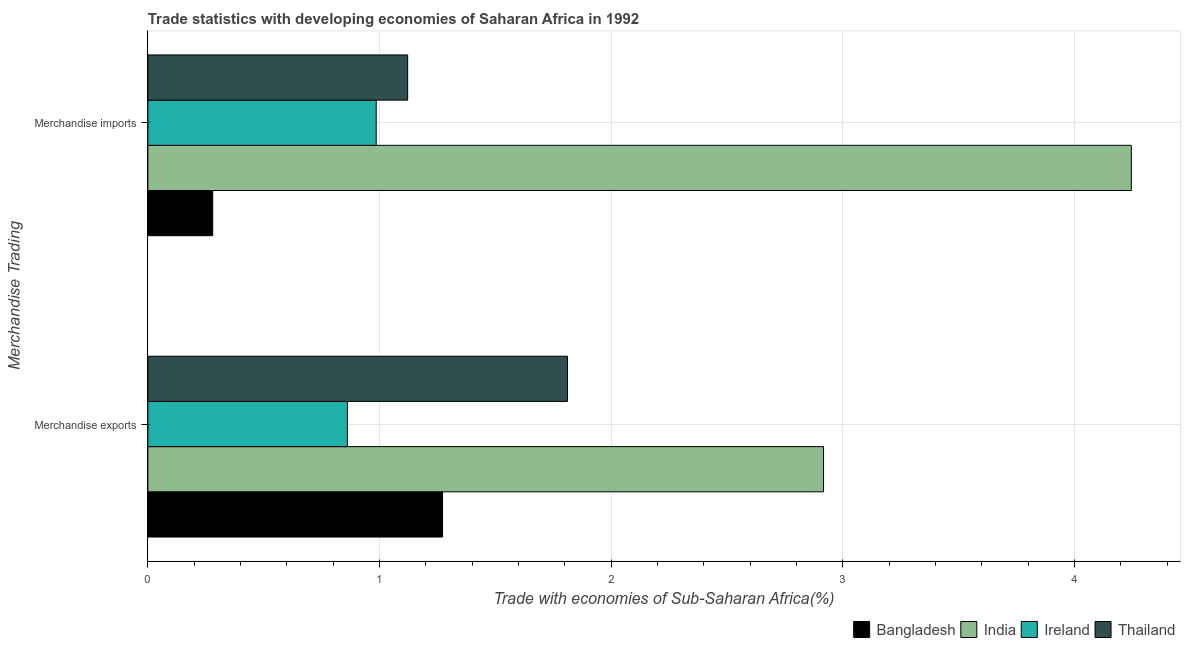How many different coloured bars are there?
Ensure brevity in your answer.  4. How many groups of bars are there?
Offer a terse response. 2. Are the number of bars per tick equal to the number of legend labels?
Offer a very short reply. Yes. What is the label of the 2nd group of bars from the top?
Your answer should be very brief. Merchandise exports. What is the merchandise exports in Bangladesh?
Provide a short and direct response. 1.27. Across all countries, what is the maximum merchandise imports?
Your answer should be very brief. 4.24. Across all countries, what is the minimum merchandise exports?
Give a very brief answer. 0.86. In which country was the merchandise imports minimum?
Your answer should be very brief. Bangladesh. What is the total merchandise imports in the graph?
Your response must be concise. 6.63. What is the difference between the merchandise exports in Bangladesh and that in India?
Keep it short and to the point. -1.64. What is the difference between the merchandise imports in India and the merchandise exports in Bangladesh?
Offer a terse response. 2.97. What is the average merchandise exports per country?
Your answer should be very brief. 1.72. What is the difference between the merchandise imports and merchandise exports in Bangladesh?
Your answer should be compact. -0.99. In how many countries, is the merchandise imports greater than 3 %?
Provide a succinct answer. 1. What is the ratio of the merchandise imports in Thailand to that in Bangladesh?
Your answer should be compact. 4.01. Is the merchandise imports in Bangladesh less than that in India?
Make the answer very short. Yes. What does the 2nd bar from the top in Merchandise imports represents?
Your answer should be very brief. Ireland. What does the 2nd bar from the bottom in Merchandise imports represents?
Give a very brief answer. India. Are the values on the major ticks of X-axis written in scientific E-notation?
Make the answer very short. No. How many legend labels are there?
Provide a short and direct response. 4. How are the legend labels stacked?
Give a very brief answer. Horizontal. What is the title of the graph?
Your answer should be compact. Trade statistics with developing economies of Saharan Africa in 1992. What is the label or title of the X-axis?
Provide a succinct answer. Trade with economies of Sub-Saharan Africa(%). What is the label or title of the Y-axis?
Provide a short and direct response. Merchandise Trading. What is the Trade with economies of Sub-Saharan Africa(%) in Bangladesh in Merchandise exports?
Keep it short and to the point. 1.27. What is the Trade with economies of Sub-Saharan Africa(%) in India in Merchandise exports?
Give a very brief answer. 2.92. What is the Trade with economies of Sub-Saharan Africa(%) of Ireland in Merchandise exports?
Your answer should be compact. 0.86. What is the Trade with economies of Sub-Saharan Africa(%) of Thailand in Merchandise exports?
Provide a short and direct response. 1.81. What is the Trade with economies of Sub-Saharan Africa(%) of Bangladesh in Merchandise imports?
Provide a succinct answer. 0.28. What is the Trade with economies of Sub-Saharan Africa(%) in India in Merchandise imports?
Your answer should be compact. 4.24. What is the Trade with economies of Sub-Saharan Africa(%) of Ireland in Merchandise imports?
Provide a succinct answer. 0.99. What is the Trade with economies of Sub-Saharan Africa(%) of Thailand in Merchandise imports?
Provide a short and direct response. 1.12. Across all Merchandise Trading, what is the maximum Trade with economies of Sub-Saharan Africa(%) in Bangladesh?
Ensure brevity in your answer.  1.27. Across all Merchandise Trading, what is the maximum Trade with economies of Sub-Saharan Africa(%) of India?
Offer a very short reply. 4.24. Across all Merchandise Trading, what is the maximum Trade with economies of Sub-Saharan Africa(%) in Ireland?
Offer a very short reply. 0.99. Across all Merchandise Trading, what is the maximum Trade with economies of Sub-Saharan Africa(%) of Thailand?
Your answer should be compact. 1.81. Across all Merchandise Trading, what is the minimum Trade with economies of Sub-Saharan Africa(%) of Bangladesh?
Your response must be concise. 0.28. Across all Merchandise Trading, what is the minimum Trade with economies of Sub-Saharan Africa(%) of India?
Ensure brevity in your answer.  2.92. Across all Merchandise Trading, what is the minimum Trade with economies of Sub-Saharan Africa(%) of Ireland?
Ensure brevity in your answer.  0.86. Across all Merchandise Trading, what is the minimum Trade with economies of Sub-Saharan Africa(%) of Thailand?
Ensure brevity in your answer.  1.12. What is the total Trade with economies of Sub-Saharan Africa(%) in Bangladesh in the graph?
Give a very brief answer. 1.55. What is the total Trade with economies of Sub-Saharan Africa(%) in India in the graph?
Your answer should be very brief. 7.16. What is the total Trade with economies of Sub-Saharan Africa(%) in Ireland in the graph?
Your answer should be compact. 1.85. What is the total Trade with economies of Sub-Saharan Africa(%) of Thailand in the graph?
Make the answer very short. 2.93. What is the difference between the Trade with economies of Sub-Saharan Africa(%) of Bangladesh in Merchandise exports and that in Merchandise imports?
Offer a terse response. 0.99. What is the difference between the Trade with economies of Sub-Saharan Africa(%) of India in Merchandise exports and that in Merchandise imports?
Offer a terse response. -1.33. What is the difference between the Trade with economies of Sub-Saharan Africa(%) of Ireland in Merchandise exports and that in Merchandise imports?
Keep it short and to the point. -0.12. What is the difference between the Trade with economies of Sub-Saharan Africa(%) of Thailand in Merchandise exports and that in Merchandise imports?
Offer a terse response. 0.69. What is the difference between the Trade with economies of Sub-Saharan Africa(%) of Bangladesh in Merchandise exports and the Trade with economies of Sub-Saharan Africa(%) of India in Merchandise imports?
Offer a very short reply. -2.97. What is the difference between the Trade with economies of Sub-Saharan Africa(%) of Bangladesh in Merchandise exports and the Trade with economies of Sub-Saharan Africa(%) of Ireland in Merchandise imports?
Give a very brief answer. 0.29. What is the difference between the Trade with economies of Sub-Saharan Africa(%) of Bangladesh in Merchandise exports and the Trade with economies of Sub-Saharan Africa(%) of Thailand in Merchandise imports?
Offer a very short reply. 0.15. What is the difference between the Trade with economies of Sub-Saharan Africa(%) of India in Merchandise exports and the Trade with economies of Sub-Saharan Africa(%) of Ireland in Merchandise imports?
Offer a very short reply. 1.93. What is the difference between the Trade with economies of Sub-Saharan Africa(%) of India in Merchandise exports and the Trade with economies of Sub-Saharan Africa(%) of Thailand in Merchandise imports?
Your response must be concise. 1.79. What is the difference between the Trade with economies of Sub-Saharan Africa(%) of Ireland in Merchandise exports and the Trade with economies of Sub-Saharan Africa(%) of Thailand in Merchandise imports?
Your answer should be very brief. -0.26. What is the average Trade with economies of Sub-Saharan Africa(%) of Bangladesh per Merchandise Trading?
Keep it short and to the point. 0.78. What is the average Trade with economies of Sub-Saharan Africa(%) in India per Merchandise Trading?
Offer a very short reply. 3.58. What is the average Trade with economies of Sub-Saharan Africa(%) in Ireland per Merchandise Trading?
Keep it short and to the point. 0.92. What is the average Trade with economies of Sub-Saharan Africa(%) of Thailand per Merchandise Trading?
Give a very brief answer. 1.47. What is the difference between the Trade with economies of Sub-Saharan Africa(%) in Bangladesh and Trade with economies of Sub-Saharan Africa(%) in India in Merchandise exports?
Keep it short and to the point. -1.64. What is the difference between the Trade with economies of Sub-Saharan Africa(%) in Bangladesh and Trade with economies of Sub-Saharan Africa(%) in Ireland in Merchandise exports?
Your response must be concise. 0.41. What is the difference between the Trade with economies of Sub-Saharan Africa(%) in Bangladesh and Trade with economies of Sub-Saharan Africa(%) in Thailand in Merchandise exports?
Provide a succinct answer. -0.54. What is the difference between the Trade with economies of Sub-Saharan Africa(%) in India and Trade with economies of Sub-Saharan Africa(%) in Ireland in Merchandise exports?
Provide a short and direct response. 2.06. What is the difference between the Trade with economies of Sub-Saharan Africa(%) in India and Trade with economies of Sub-Saharan Africa(%) in Thailand in Merchandise exports?
Offer a very short reply. 1.11. What is the difference between the Trade with economies of Sub-Saharan Africa(%) in Ireland and Trade with economies of Sub-Saharan Africa(%) in Thailand in Merchandise exports?
Your answer should be very brief. -0.95. What is the difference between the Trade with economies of Sub-Saharan Africa(%) in Bangladesh and Trade with economies of Sub-Saharan Africa(%) in India in Merchandise imports?
Offer a terse response. -3.96. What is the difference between the Trade with economies of Sub-Saharan Africa(%) in Bangladesh and Trade with economies of Sub-Saharan Africa(%) in Ireland in Merchandise imports?
Your answer should be very brief. -0.71. What is the difference between the Trade with economies of Sub-Saharan Africa(%) in Bangladesh and Trade with economies of Sub-Saharan Africa(%) in Thailand in Merchandise imports?
Keep it short and to the point. -0.84. What is the difference between the Trade with economies of Sub-Saharan Africa(%) of India and Trade with economies of Sub-Saharan Africa(%) of Ireland in Merchandise imports?
Provide a succinct answer. 3.26. What is the difference between the Trade with economies of Sub-Saharan Africa(%) of India and Trade with economies of Sub-Saharan Africa(%) of Thailand in Merchandise imports?
Make the answer very short. 3.12. What is the difference between the Trade with economies of Sub-Saharan Africa(%) in Ireland and Trade with economies of Sub-Saharan Africa(%) in Thailand in Merchandise imports?
Your answer should be very brief. -0.14. What is the ratio of the Trade with economies of Sub-Saharan Africa(%) of Bangladesh in Merchandise exports to that in Merchandise imports?
Make the answer very short. 4.54. What is the ratio of the Trade with economies of Sub-Saharan Africa(%) of India in Merchandise exports to that in Merchandise imports?
Your answer should be very brief. 0.69. What is the ratio of the Trade with economies of Sub-Saharan Africa(%) in Ireland in Merchandise exports to that in Merchandise imports?
Provide a short and direct response. 0.87. What is the ratio of the Trade with economies of Sub-Saharan Africa(%) of Thailand in Merchandise exports to that in Merchandise imports?
Provide a succinct answer. 1.62. What is the difference between the highest and the second highest Trade with economies of Sub-Saharan Africa(%) in Bangladesh?
Your answer should be very brief. 0.99. What is the difference between the highest and the second highest Trade with economies of Sub-Saharan Africa(%) of India?
Your answer should be very brief. 1.33. What is the difference between the highest and the second highest Trade with economies of Sub-Saharan Africa(%) in Ireland?
Your response must be concise. 0.12. What is the difference between the highest and the second highest Trade with economies of Sub-Saharan Africa(%) of Thailand?
Your response must be concise. 0.69. What is the difference between the highest and the lowest Trade with economies of Sub-Saharan Africa(%) of India?
Your answer should be very brief. 1.33. What is the difference between the highest and the lowest Trade with economies of Sub-Saharan Africa(%) in Ireland?
Your answer should be compact. 0.12. What is the difference between the highest and the lowest Trade with economies of Sub-Saharan Africa(%) of Thailand?
Give a very brief answer. 0.69. 